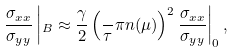Convert formula to latex. <formula><loc_0><loc_0><loc_500><loc_500>\frac { \sigma _ { x x } } { \sigma _ { y y } } \left | _ { B } \approx \frac { \gamma } { 2 } \left ( \frac { } { \tau } \pi n ( \mu ) \right ) ^ { 2 } \frac { \sigma _ { x x } } { \sigma _ { y y } } \right | _ { 0 } ,</formula> 